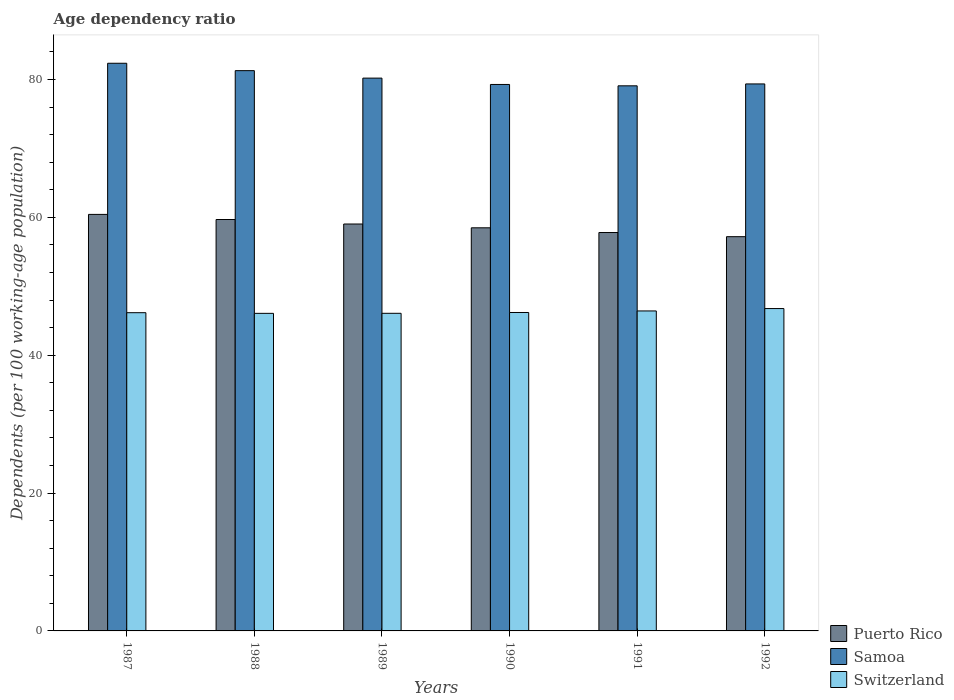How many groups of bars are there?
Give a very brief answer. 6. Are the number of bars per tick equal to the number of legend labels?
Your answer should be very brief. Yes. Are the number of bars on each tick of the X-axis equal?
Offer a very short reply. Yes. What is the label of the 4th group of bars from the left?
Offer a terse response. 1990. In how many cases, is the number of bars for a given year not equal to the number of legend labels?
Keep it short and to the point. 0. What is the age dependency ratio in in Puerto Rico in 1987?
Keep it short and to the point. 60.42. Across all years, what is the maximum age dependency ratio in in Samoa?
Provide a succinct answer. 82.35. Across all years, what is the minimum age dependency ratio in in Switzerland?
Ensure brevity in your answer.  46.07. What is the total age dependency ratio in in Puerto Rico in the graph?
Your response must be concise. 352.6. What is the difference between the age dependency ratio in in Switzerland in 1988 and that in 1990?
Your answer should be compact. -0.12. What is the difference between the age dependency ratio in in Switzerland in 1988 and the age dependency ratio in in Samoa in 1989?
Give a very brief answer. -34.12. What is the average age dependency ratio in in Samoa per year?
Provide a short and direct response. 80.25. In the year 1990, what is the difference between the age dependency ratio in in Switzerland and age dependency ratio in in Puerto Rico?
Keep it short and to the point. -12.28. In how many years, is the age dependency ratio in in Puerto Rico greater than 68 %?
Offer a very short reply. 0. What is the ratio of the age dependency ratio in in Puerto Rico in 1989 to that in 1990?
Offer a very short reply. 1.01. Is the age dependency ratio in in Samoa in 1990 less than that in 1991?
Offer a very short reply. No. Is the difference between the age dependency ratio in in Switzerland in 1987 and 1992 greater than the difference between the age dependency ratio in in Puerto Rico in 1987 and 1992?
Provide a succinct answer. No. What is the difference between the highest and the second highest age dependency ratio in in Switzerland?
Give a very brief answer. 0.35. What is the difference between the highest and the lowest age dependency ratio in in Puerto Rico?
Provide a short and direct response. 3.23. Is the sum of the age dependency ratio in in Switzerland in 1988 and 1991 greater than the maximum age dependency ratio in in Samoa across all years?
Keep it short and to the point. Yes. What does the 3rd bar from the left in 1988 represents?
Provide a short and direct response. Switzerland. What does the 3rd bar from the right in 1988 represents?
Offer a terse response. Puerto Rico. Is it the case that in every year, the sum of the age dependency ratio in in Samoa and age dependency ratio in in Switzerland is greater than the age dependency ratio in in Puerto Rico?
Your response must be concise. Yes. How many years are there in the graph?
Keep it short and to the point. 6. What is the difference between two consecutive major ticks on the Y-axis?
Offer a terse response. 20. How many legend labels are there?
Give a very brief answer. 3. What is the title of the graph?
Provide a succinct answer. Age dependency ratio. What is the label or title of the X-axis?
Offer a very short reply. Years. What is the label or title of the Y-axis?
Offer a terse response. Dependents (per 100 working-age population). What is the Dependents (per 100 working-age population) of Puerto Rico in 1987?
Offer a very short reply. 60.42. What is the Dependents (per 100 working-age population) in Samoa in 1987?
Give a very brief answer. 82.35. What is the Dependents (per 100 working-age population) in Switzerland in 1987?
Keep it short and to the point. 46.16. What is the Dependents (per 100 working-age population) of Puerto Rico in 1988?
Ensure brevity in your answer.  59.68. What is the Dependents (per 100 working-age population) in Samoa in 1988?
Offer a very short reply. 81.28. What is the Dependents (per 100 working-age population) in Switzerland in 1988?
Your answer should be compact. 46.07. What is the Dependents (per 100 working-age population) of Puerto Rico in 1989?
Provide a short and direct response. 59.03. What is the Dependents (per 100 working-age population) in Samoa in 1989?
Your response must be concise. 80.19. What is the Dependents (per 100 working-age population) of Switzerland in 1989?
Keep it short and to the point. 46.08. What is the Dependents (per 100 working-age population) in Puerto Rico in 1990?
Make the answer very short. 58.48. What is the Dependents (per 100 working-age population) of Samoa in 1990?
Offer a very short reply. 79.27. What is the Dependents (per 100 working-age population) in Switzerland in 1990?
Provide a short and direct response. 46.19. What is the Dependents (per 100 working-age population) of Puerto Rico in 1991?
Provide a short and direct response. 57.79. What is the Dependents (per 100 working-age population) of Samoa in 1991?
Your answer should be compact. 79.08. What is the Dependents (per 100 working-age population) of Switzerland in 1991?
Offer a very short reply. 46.42. What is the Dependents (per 100 working-age population) in Puerto Rico in 1992?
Give a very brief answer. 57.19. What is the Dependents (per 100 working-age population) in Samoa in 1992?
Offer a very short reply. 79.35. What is the Dependents (per 100 working-age population) of Switzerland in 1992?
Keep it short and to the point. 46.76. Across all years, what is the maximum Dependents (per 100 working-age population) in Puerto Rico?
Your answer should be very brief. 60.42. Across all years, what is the maximum Dependents (per 100 working-age population) of Samoa?
Provide a succinct answer. 82.35. Across all years, what is the maximum Dependents (per 100 working-age population) of Switzerland?
Give a very brief answer. 46.76. Across all years, what is the minimum Dependents (per 100 working-age population) of Puerto Rico?
Offer a terse response. 57.19. Across all years, what is the minimum Dependents (per 100 working-age population) in Samoa?
Offer a very short reply. 79.08. Across all years, what is the minimum Dependents (per 100 working-age population) in Switzerland?
Keep it short and to the point. 46.07. What is the total Dependents (per 100 working-age population) of Puerto Rico in the graph?
Your answer should be compact. 352.6. What is the total Dependents (per 100 working-age population) in Samoa in the graph?
Keep it short and to the point. 481.52. What is the total Dependents (per 100 working-age population) in Switzerland in the graph?
Your answer should be very brief. 277.69. What is the difference between the Dependents (per 100 working-age population) in Puerto Rico in 1987 and that in 1988?
Provide a short and direct response. 0.74. What is the difference between the Dependents (per 100 working-age population) of Samoa in 1987 and that in 1988?
Offer a terse response. 1.07. What is the difference between the Dependents (per 100 working-age population) in Switzerland in 1987 and that in 1988?
Make the answer very short. 0.09. What is the difference between the Dependents (per 100 working-age population) of Puerto Rico in 1987 and that in 1989?
Your response must be concise. 1.39. What is the difference between the Dependents (per 100 working-age population) of Samoa in 1987 and that in 1989?
Your answer should be very brief. 2.16. What is the difference between the Dependents (per 100 working-age population) of Switzerland in 1987 and that in 1989?
Your answer should be very brief. 0.09. What is the difference between the Dependents (per 100 working-age population) in Puerto Rico in 1987 and that in 1990?
Make the answer very short. 1.94. What is the difference between the Dependents (per 100 working-age population) of Samoa in 1987 and that in 1990?
Offer a terse response. 3.07. What is the difference between the Dependents (per 100 working-age population) of Switzerland in 1987 and that in 1990?
Offer a very short reply. -0.03. What is the difference between the Dependents (per 100 working-age population) of Puerto Rico in 1987 and that in 1991?
Make the answer very short. 2.63. What is the difference between the Dependents (per 100 working-age population) in Samoa in 1987 and that in 1991?
Your answer should be compact. 3.27. What is the difference between the Dependents (per 100 working-age population) of Switzerland in 1987 and that in 1991?
Give a very brief answer. -0.25. What is the difference between the Dependents (per 100 working-age population) in Puerto Rico in 1987 and that in 1992?
Keep it short and to the point. 3.23. What is the difference between the Dependents (per 100 working-age population) in Samoa in 1987 and that in 1992?
Your answer should be very brief. 3. What is the difference between the Dependents (per 100 working-age population) of Switzerland in 1987 and that in 1992?
Keep it short and to the point. -0.6. What is the difference between the Dependents (per 100 working-age population) of Puerto Rico in 1988 and that in 1989?
Your response must be concise. 0.65. What is the difference between the Dependents (per 100 working-age population) in Samoa in 1988 and that in 1989?
Provide a succinct answer. 1.08. What is the difference between the Dependents (per 100 working-age population) in Switzerland in 1988 and that in 1989?
Make the answer very short. -0.01. What is the difference between the Dependents (per 100 working-age population) in Puerto Rico in 1988 and that in 1990?
Offer a very short reply. 1.2. What is the difference between the Dependents (per 100 working-age population) in Samoa in 1988 and that in 1990?
Offer a very short reply. 2. What is the difference between the Dependents (per 100 working-age population) of Switzerland in 1988 and that in 1990?
Provide a succinct answer. -0.12. What is the difference between the Dependents (per 100 working-age population) in Puerto Rico in 1988 and that in 1991?
Your answer should be compact. 1.89. What is the difference between the Dependents (per 100 working-age population) of Samoa in 1988 and that in 1991?
Offer a terse response. 2.2. What is the difference between the Dependents (per 100 working-age population) in Switzerland in 1988 and that in 1991?
Your answer should be compact. -0.35. What is the difference between the Dependents (per 100 working-age population) of Puerto Rico in 1988 and that in 1992?
Make the answer very short. 2.49. What is the difference between the Dependents (per 100 working-age population) in Samoa in 1988 and that in 1992?
Offer a very short reply. 1.93. What is the difference between the Dependents (per 100 working-age population) in Switzerland in 1988 and that in 1992?
Your response must be concise. -0.69. What is the difference between the Dependents (per 100 working-age population) of Puerto Rico in 1989 and that in 1990?
Ensure brevity in your answer.  0.55. What is the difference between the Dependents (per 100 working-age population) of Samoa in 1989 and that in 1990?
Your response must be concise. 0.92. What is the difference between the Dependents (per 100 working-age population) of Switzerland in 1989 and that in 1990?
Your response must be concise. -0.12. What is the difference between the Dependents (per 100 working-age population) in Puerto Rico in 1989 and that in 1991?
Your answer should be very brief. 1.23. What is the difference between the Dependents (per 100 working-age population) of Samoa in 1989 and that in 1991?
Offer a terse response. 1.12. What is the difference between the Dependents (per 100 working-age population) of Switzerland in 1989 and that in 1991?
Ensure brevity in your answer.  -0.34. What is the difference between the Dependents (per 100 working-age population) of Puerto Rico in 1989 and that in 1992?
Keep it short and to the point. 1.84. What is the difference between the Dependents (per 100 working-age population) of Samoa in 1989 and that in 1992?
Your response must be concise. 0.84. What is the difference between the Dependents (per 100 working-age population) in Switzerland in 1989 and that in 1992?
Make the answer very short. -0.69. What is the difference between the Dependents (per 100 working-age population) of Puerto Rico in 1990 and that in 1991?
Your answer should be very brief. 0.68. What is the difference between the Dependents (per 100 working-age population) in Samoa in 1990 and that in 1991?
Your answer should be compact. 0.2. What is the difference between the Dependents (per 100 working-age population) in Switzerland in 1990 and that in 1991?
Provide a short and direct response. -0.22. What is the difference between the Dependents (per 100 working-age population) of Puerto Rico in 1990 and that in 1992?
Make the answer very short. 1.29. What is the difference between the Dependents (per 100 working-age population) in Samoa in 1990 and that in 1992?
Your answer should be compact. -0.08. What is the difference between the Dependents (per 100 working-age population) of Switzerland in 1990 and that in 1992?
Your answer should be very brief. -0.57. What is the difference between the Dependents (per 100 working-age population) of Puerto Rico in 1991 and that in 1992?
Provide a short and direct response. 0.6. What is the difference between the Dependents (per 100 working-age population) in Samoa in 1991 and that in 1992?
Provide a succinct answer. -0.27. What is the difference between the Dependents (per 100 working-age population) of Switzerland in 1991 and that in 1992?
Your response must be concise. -0.35. What is the difference between the Dependents (per 100 working-age population) in Puerto Rico in 1987 and the Dependents (per 100 working-age population) in Samoa in 1988?
Offer a very short reply. -20.86. What is the difference between the Dependents (per 100 working-age population) in Puerto Rico in 1987 and the Dependents (per 100 working-age population) in Switzerland in 1988?
Offer a terse response. 14.35. What is the difference between the Dependents (per 100 working-age population) of Samoa in 1987 and the Dependents (per 100 working-age population) of Switzerland in 1988?
Offer a very short reply. 36.28. What is the difference between the Dependents (per 100 working-age population) of Puerto Rico in 1987 and the Dependents (per 100 working-age population) of Samoa in 1989?
Offer a very short reply. -19.77. What is the difference between the Dependents (per 100 working-age population) in Puerto Rico in 1987 and the Dependents (per 100 working-age population) in Switzerland in 1989?
Provide a succinct answer. 14.35. What is the difference between the Dependents (per 100 working-age population) in Samoa in 1987 and the Dependents (per 100 working-age population) in Switzerland in 1989?
Give a very brief answer. 36.27. What is the difference between the Dependents (per 100 working-age population) of Puerto Rico in 1987 and the Dependents (per 100 working-age population) of Samoa in 1990?
Your answer should be very brief. -18.85. What is the difference between the Dependents (per 100 working-age population) in Puerto Rico in 1987 and the Dependents (per 100 working-age population) in Switzerland in 1990?
Ensure brevity in your answer.  14.23. What is the difference between the Dependents (per 100 working-age population) in Samoa in 1987 and the Dependents (per 100 working-age population) in Switzerland in 1990?
Provide a succinct answer. 36.15. What is the difference between the Dependents (per 100 working-age population) of Puerto Rico in 1987 and the Dependents (per 100 working-age population) of Samoa in 1991?
Offer a very short reply. -18.65. What is the difference between the Dependents (per 100 working-age population) of Puerto Rico in 1987 and the Dependents (per 100 working-age population) of Switzerland in 1991?
Make the answer very short. 14. What is the difference between the Dependents (per 100 working-age population) in Samoa in 1987 and the Dependents (per 100 working-age population) in Switzerland in 1991?
Give a very brief answer. 35.93. What is the difference between the Dependents (per 100 working-age population) of Puerto Rico in 1987 and the Dependents (per 100 working-age population) of Samoa in 1992?
Ensure brevity in your answer.  -18.93. What is the difference between the Dependents (per 100 working-age population) in Puerto Rico in 1987 and the Dependents (per 100 working-age population) in Switzerland in 1992?
Provide a succinct answer. 13.66. What is the difference between the Dependents (per 100 working-age population) in Samoa in 1987 and the Dependents (per 100 working-age population) in Switzerland in 1992?
Your answer should be very brief. 35.58. What is the difference between the Dependents (per 100 working-age population) in Puerto Rico in 1988 and the Dependents (per 100 working-age population) in Samoa in 1989?
Offer a very short reply. -20.51. What is the difference between the Dependents (per 100 working-age population) in Puerto Rico in 1988 and the Dependents (per 100 working-age population) in Switzerland in 1989?
Your answer should be compact. 13.61. What is the difference between the Dependents (per 100 working-age population) in Samoa in 1988 and the Dependents (per 100 working-age population) in Switzerland in 1989?
Your answer should be very brief. 35.2. What is the difference between the Dependents (per 100 working-age population) of Puerto Rico in 1988 and the Dependents (per 100 working-age population) of Samoa in 1990?
Provide a succinct answer. -19.59. What is the difference between the Dependents (per 100 working-age population) in Puerto Rico in 1988 and the Dependents (per 100 working-age population) in Switzerland in 1990?
Your answer should be very brief. 13.49. What is the difference between the Dependents (per 100 working-age population) of Samoa in 1988 and the Dependents (per 100 working-age population) of Switzerland in 1990?
Provide a short and direct response. 35.08. What is the difference between the Dependents (per 100 working-age population) of Puerto Rico in 1988 and the Dependents (per 100 working-age population) of Samoa in 1991?
Give a very brief answer. -19.39. What is the difference between the Dependents (per 100 working-age population) in Puerto Rico in 1988 and the Dependents (per 100 working-age population) in Switzerland in 1991?
Offer a very short reply. 13.26. What is the difference between the Dependents (per 100 working-age population) of Samoa in 1988 and the Dependents (per 100 working-age population) of Switzerland in 1991?
Offer a very short reply. 34.86. What is the difference between the Dependents (per 100 working-age population) of Puerto Rico in 1988 and the Dependents (per 100 working-age population) of Samoa in 1992?
Keep it short and to the point. -19.67. What is the difference between the Dependents (per 100 working-age population) in Puerto Rico in 1988 and the Dependents (per 100 working-age population) in Switzerland in 1992?
Provide a succinct answer. 12.92. What is the difference between the Dependents (per 100 working-age population) of Samoa in 1988 and the Dependents (per 100 working-age population) of Switzerland in 1992?
Your answer should be very brief. 34.51. What is the difference between the Dependents (per 100 working-age population) of Puerto Rico in 1989 and the Dependents (per 100 working-age population) of Samoa in 1990?
Make the answer very short. -20.24. What is the difference between the Dependents (per 100 working-age population) of Puerto Rico in 1989 and the Dependents (per 100 working-age population) of Switzerland in 1990?
Offer a very short reply. 12.83. What is the difference between the Dependents (per 100 working-age population) in Samoa in 1989 and the Dependents (per 100 working-age population) in Switzerland in 1990?
Offer a very short reply. 34. What is the difference between the Dependents (per 100 working-age population) in Puerto Rico in 1989 and the Dependents (per 100 working-age population) in Samoa in 1991?
Give a very brief answer. -20.05. What is the difference between the Dependents (per 100 working-age population) of Puerto Rico in 1989 and the Dependents (per 100 working-age population) of Switzerland in 1991?
Offer a very short reply. 12.61. What is the difference between the Dependents (per 100 working-age population) in Samoa in 1989 and the Dependents (per 100 working-age population) in Switzerland in 1991?
Keep it short and to the point. 33.78. What is the difference between the Dependents (per 100 working-age population) in Puerto Rico in 1989 and the Dependents (per 100 working-age population) in Samoa in 1992?
Offer a terse response. -20.32. What is the difference between the Dependents (per 100 working-age population) in Puerto Rico in 1989 and the Dependents (per 100 working-age population) in Switzerland in 1992?
Provide a succinct answer. 12.27. What is the difference between the Dependents (per 100 working-age population) of Samoa in 1989 and the Dependents (per 100 working-age population) of Switzerland in 1992?
Make the answer very short. 33.43. What is the difference between the Dependents (per 100 working-age population) of Puerto Rico in 1990 and the Dependents (per 100 working-age population) of Samoa in 1991?
Make the answer very short. -20.6. What is the difference between the Dependents (per 100 working-age population) in Puerto Rico in 1990 and the Dependents (per 100 working-age population) in Switzerland in 1991?
Provide a short and direct response. 12.06. What is the difference between the Dependents (per 100 working-age population) of Samoa in 1990 and the Dependents (per 100 working-age population) of Switzerland in 1991?
Offer a very short reply. 32.86. What is the difference between the Dependents (per 100 working-age population) of Puerto Rico in 1990 and the Dependents (per 100 working-age population) of Samoa in 1992?
Offer a very short reply. -20.87. What is the difference between the Dependents (per 100 working-age population) in Puerto Rico in 1990 and the Dependents (per 100 working-age population) in Switzerland in 1992?
Provide a short and direct response. 11.71. What is the difference between the Dependents (per 100 working-age population) of Samoa in 1990 and the Dependents (per 100 working-age population) of Switzerland in 1992?
Give a very brief answer. 32.51. What is the difference between the Dependents (per 100 working-age population) in Puerto Rico in 1991 and the Dependents (per 100 working-age population) in Samoa in 1992?
Provide a succinct answer. -21.55. What is the difference between the Dependents (per 100 working-age population) in Puerto Rico in 1991 and the Dependents (per 100 working-age population) in Switzerland in 1992?
Ensure brevity in your answer.  11.03. What is the difference between the Dependents (per 100 working-age population) of Samoa in 1991 and the Dependents (per 100 working-age population) of Switzerland in 1992?
Provide a succinct answer. 32.31. What is the average Dependents (per 100 working-age population) of Puerto Rico per year?
Your answer should be compact. 58.77. What is the average Dependents (per 100 working-age population) in Samoa per year?
Offer a terse response. 80.25. What is the average Dependents (per 100 working-age population) in Switzerland per year?
Provide a short and direct response. 46.28. In the year 1987, what is the difference between the Dependents (per 100 working-age population) in Puerto Rico and Dependents (per 100 working-age population) in Samoa?
Offer a very short reply. -21.93. In the year 1987, what is the difference between the Dependents (per 100 working-age population) of Puerto Rico and Dependents (per 100 working-age population) of Switzerland?
Provide a short and direct response. 14.26. In the year 1987, what is the difference between the Dependents (per 100 working-age population) in Samoa and Dependents (per 100 working-age population) in Switzerland?
Ensure brevity in your answer.  36.18. In the year 1988, what is the difference between the Dependents (per 100 working-age population) of Puerto Rico and Dependents (per 100 working-age population) of Samoa?
Provide a short and direct response. -21.6. In the year 1988, what is the difference between the Dependents (per 100 working-age population) of Puerto Rico and Dependents (per 100 working-age population) of Switzerland?
Ensure brevity in your answer.  13.61. In the year 1988, what is the difference between the Dependents (per 100 working-age population) of Samoa and Dependents (per 100 working-age population) of Switzerland?
Provide a succinct answer. 35.21. In the year 1989, what is the difference between the Dependents (per 100 working-age population) of Puerto Rico and Dependents (per 100 working-age population) of Samoa?
Keep it short and to the point. -21.16. In the year 1989, what is the difference between the Dependents (per 100 working-age population) in Puerto Rico and Dependents (per 100 working-age population) in Switzerland?
Your answer should be compact. 12.95. In the year 1989, what is the difference between the Dependents (per 100 working-age population) in Samoa and Dependents (per 100 working-age population) in Switzerland?
Keep it short and to the point. 34.12. In the year 1990, what is the difference between the Dependents (per 100 working-age population) in Puerto Rico and Dependents (per 100 working-age population) in Samoa?
Your answer should be very brief. -20.8. In the year 1990, what is the difference between the Dependents (per 100 working-age population) in Puerto Rico and Dependents (per 100 working-age population) in Switzerland?
Give a very brief answer. 12.28. In the year 1990, what is the difference between the Dependents (per 100 working-age population) of Samoa and Dependents (per 100 working-age population) of Switzerland?
Offer a terse response. 33.08. In the year 1991, what is the difference between the Dependents (per 100 working-age population) of Puerto Rico and Dependents (per 100 working-age population) of Samoa?
Make the answer very short. -21.28. In the year 1991, what is the difference between the Dependents (per 100 working-age population) in Puerto Rico and Dependents (per 100 working-age population) in Switzerland?
Provide a succinct answer. 11.38. In the year 1991, what is the difference between the Dependents (per 100 working-age population) of Samoa and Dependents (per 100 working-age population) of Switzerland?
Keep it short and to the point. 32.66. In the year 1992, what is the difference between the Dependents (per 100 working-age population) in Puerto Rico and Dependents (per 100 working-age population) in Samoa?
Offer a terse response. -22.16. In the year 1992, what is the difference between the Dependents (per 100 working-age population) in Puerto Rico and Dependents (per 100 working-age population) in Switzerland?
Offer a very short reply. 10.43. In the year 1992, what is the difference between the Dependents (per 100 working-age population) in Samoa and Dependents (per 100 working-age population) in Switzerland?
Give a very brief answer. 32.59. What is the ratio of the Dependents (per 100 working-age population) in Puerto Rico in 1987 to that in 1988?
Ensure brevity in your answer.  1.01. What is the ratio of the Dependents (per 100 working-age population) of Samoa in 1987 to that in 1988?
Ensure brevity in your answer.  1.01. What is the ratio of the Dependents (per 100 working-age population) of Switzerland in 1987 to that in 1988?
Offer a terse response. 1. What is the ratio of the Dependents (per 100 working-age population) in Puerto Rico in 1987 to that in 1989?
Your answer should be compact. 1.02. What is the ratio of the Dependents (per 100 working-age population) in Samoa in 1987 to that in 1989?
Offer a very short reply. 1.03. What is the ratio of the Dependents (per 100 working-age population) of Switzerland in 1987 to that in 1989?
Keep it short and to the point. 1. What is the ratio of the Dependents (per 100 working-age population) of Puerto Rico in 1987 to that in 1990?
Your answer should be very brief. 1.03. What is the ratio of the Dependents (per 100 working-age population) of Samoa in 1987 to that in 1990?
Your response must be concise. 1.04. What is the ratio of the Dependents (per 100 working-age population) of Switzerland in 1987 to that in 1990?
Offer a terse response. 1. What is the ratio of the Dependents (per 100 working-age population) of Puerto Rico in 1987 to that in 1991?
Make the answer very short. 1.05. What is the ratio of the Dependents (per 100 working-age population) in Samoa in 1987 to that in 1991?
Offer a terse response. 1.04. What is the ratio of the Dependents (per 100 working-age population) in Puerto Rico in 1987 to that in 1992?
Your answer should be compact. 1.06. What is the ratio of the Dependents (per 100 working-age population) in Samoa in 1987 to that in 1992?
Provide a short and direct response. 1.04. What is the ratio of the Dependents (per 100 working-age population) in Switzerland in 1987 to that in 1992?
Offer a very short reply. 0.99. What is the ratio of the Dependents (per 100 working-age population) of Puerto Rico in 1988 to that in 1989?
Offer a very short reply. 1.01. What is the ratio of the Dependents (per 100 working-age population) in Samoa in 1988 to that in 1989?
Your response must be concise. 1.01. What is the ratio of the Dependents (per 100 working-age population) of Puerto Rico in 1988 to that in 1990?
Your answer should be compact. 1.02. What is the ratio of the Dependents (per 100 working-age population) in Samoa in 1988 to that in 1990?
Keep it short and to the point. 1.03. What is the ratio of the Dependents (per 100 working-age population) of Switzerland in 1988 to that in 1990?
Give a very brief answer. 1. What is the ratio of the Dependents (per 100 working-age population) of Puerto Rico in 1988 to that in 1991?
Your response must be concise. 1.03. What is the ratio of the Dependents (per 100 working-age population) of Samoa in 1988 to that in 1991?
Your answer should be compact. 1.03. What is the ratio of the Dependents (per 100 working-age population) of Puerto Rico in 1988 to that in 1992?
Make the answer very short. 1.04. What is the ratio of the Dependents (per 100 working-age population) of Samoa in 1988 to that in 1992?
Provide a succinct answer. 1.02. What is the ratio of the Dependents (per 100 working-age population) in Switzerland in 1988 to that in 1992?
Your answer should be compact. 0.99. What is the ratio of the Dependents (per 100 working-age population) in Puerto Rico in 1989 to that in 1990?
Offer a very short reply. 1.01. What is the ratio of the Dependents (per 100 working-age population) in Samoa in 1989 to that in 1990?
Your answer should be very brief. 1.01. What is the ratio of the Dependents (per 100 working-age population) in Switzerland in 1989 to that in 1990?
Provide a short and direct response. 1. What is the ratio of the Dependents (per 100 working-age population) of Puerto Rico in 1989 to that in 1991?
Offer a terse response. 1.02. What is the ratio of the Dependents (per 100 working-age population) in Samoa in 1989 to that in 1991?
Make the answer very short. 1.01. What is the ratio of the Dependents (per 100 working-age population) in Puerto Rico in 1989 to that in 1992?
Your response must be concise. 1.03. What is the ratio of the Dependents (per 100 working-age population) of Samoa in 1989 to that in 1992?
Provide a short and direct response. 1.01. What is the ratio of the Dependents (per 100 working-age population) of Puerto Rico in 1990 to that in 1991?
Make the answer very short. 1.01. What is the ratio of the Dependents (per 100 working-age population) in Puerto Rico in 1990 to that in 1992?
Make the answer very short. 1.02. What is the ratio of the Dependents (per 100 working-age population) in Puerto Rico in 1991 to that in 1992?
Offer a very short reply. 1.01. What is the ratio of the Dependents (per 100 working-age population) of Samoa in 1991 to that in 1992?
Your response must be concise. 1. What is the ratio of the Dependents (per 100 working-age population) of Switzerland in 1991 to that in 1992?
Make the answer very short. 0.99. What is the difference between the highest and the second highest Dependents (per 100 working-age population) of Puerto Rico?
Your answer should be compact. 0.74. What is the difference between the highest and the second highest Dependents (per 100 working-age population) of Samoa?
Make the answer very short. 1.07. What is the difference between the highest and the second highest Dependents (per 100 working-age population) of Switzerland?
Give a very brief answer. 0.35. What is the difference between the highest and the lowest Dependents (per 100 working-age population) of Puerto Rico?
Offer a terse response. 3.23. What is the difference between the highest and the lowest Dependents (per 100 working-age population) of Samoa?
Your answer should be very brief. 3.27. What is the difference between the highest and the lowest Dependents (per 100 working-age population) in Switzerland?
Offer a terse response. 0.69. 